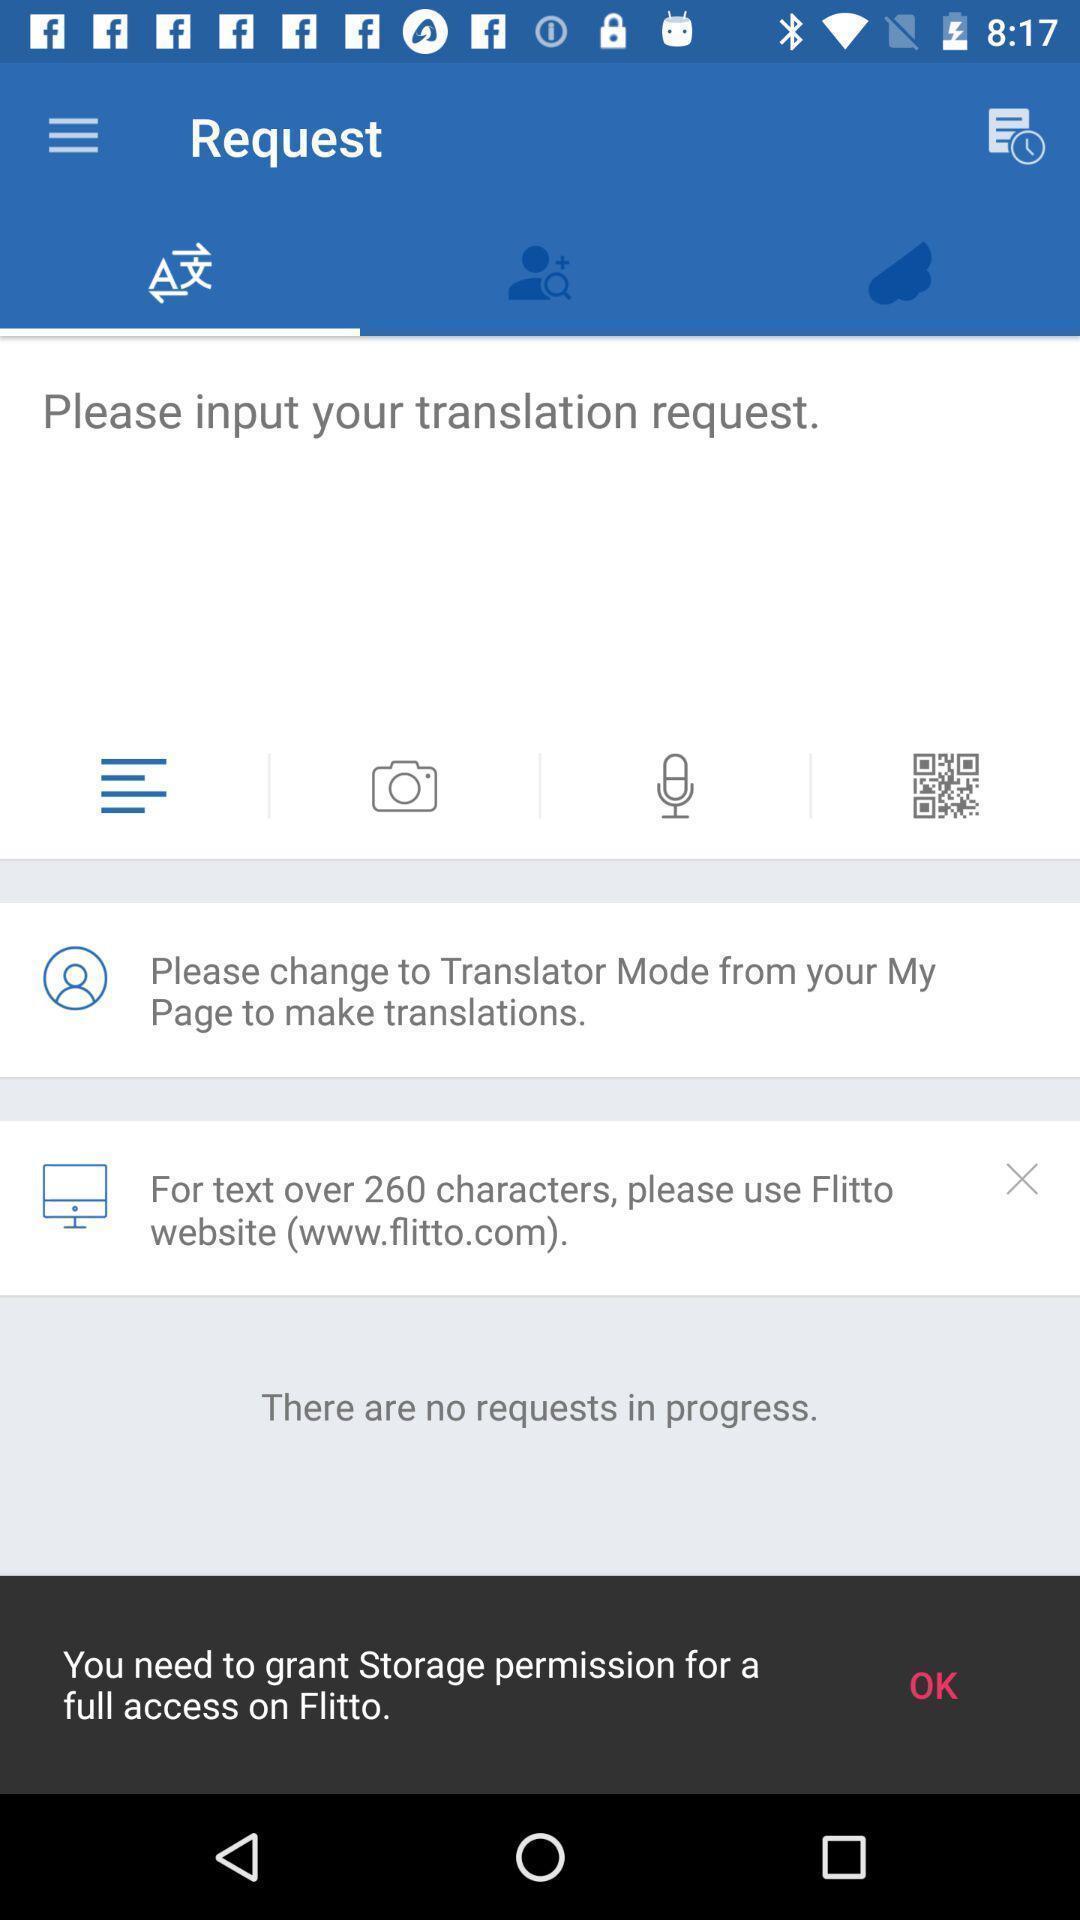Describe the key features of this screenshot. Translation request in the app. 